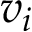Convert formula to latex. <formula><loc_0><loc_0><loc_500><loc_500>v _ { i }</formula> 